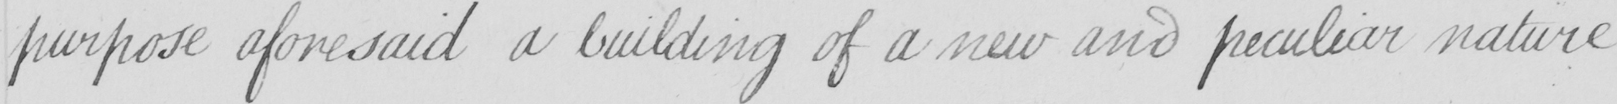Transcribe the text shown in this historical manuscript line. purpose aforesaid a building of a new and peculiar nature 